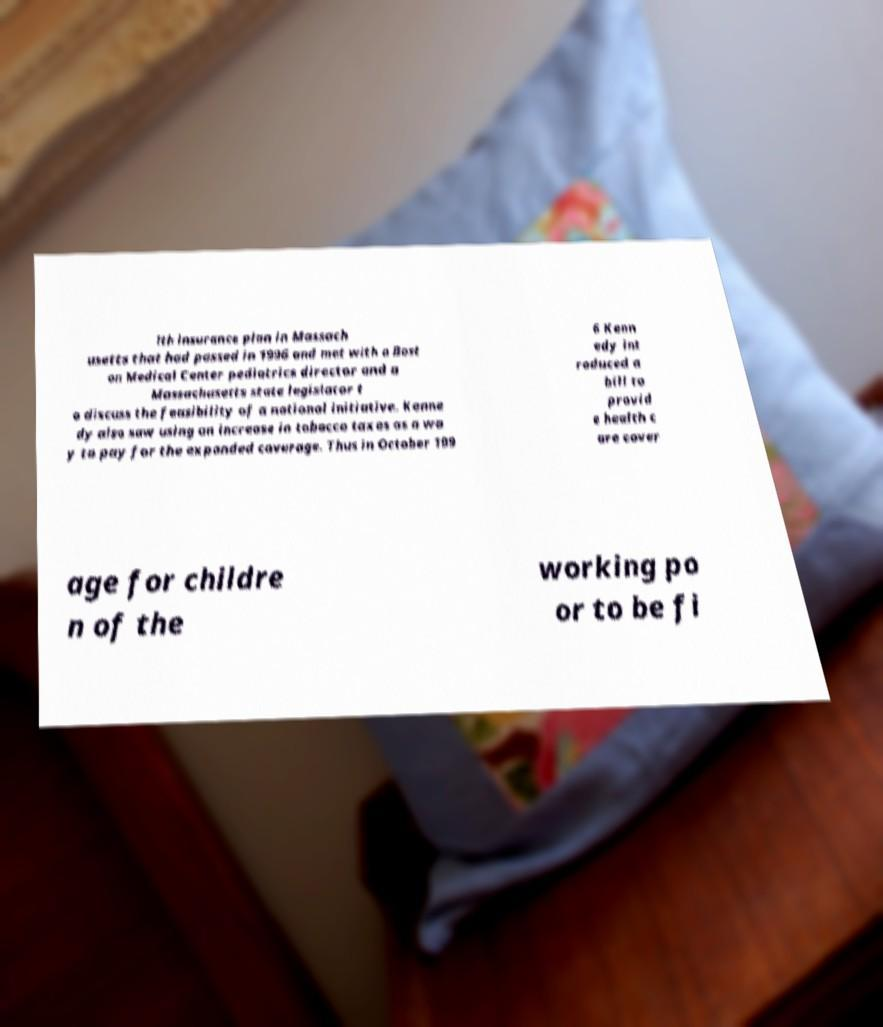I need the written content from this picture converted into text. Can you do that? lth insurance plan in Massach usetts that had passed in 1996 and met with a Bost on Medical Center pediatrics director and a Massachusetts state legislator t o discuss the feasibility of a national initiative. Kenne dy also saw using an increase in tobacco taxes as a wa y to pay for the expanded coverage. Thus in October 199 6 Kenn edy int roduced a bill to provid e health c are cover age for childre n of the working po or to be fi 